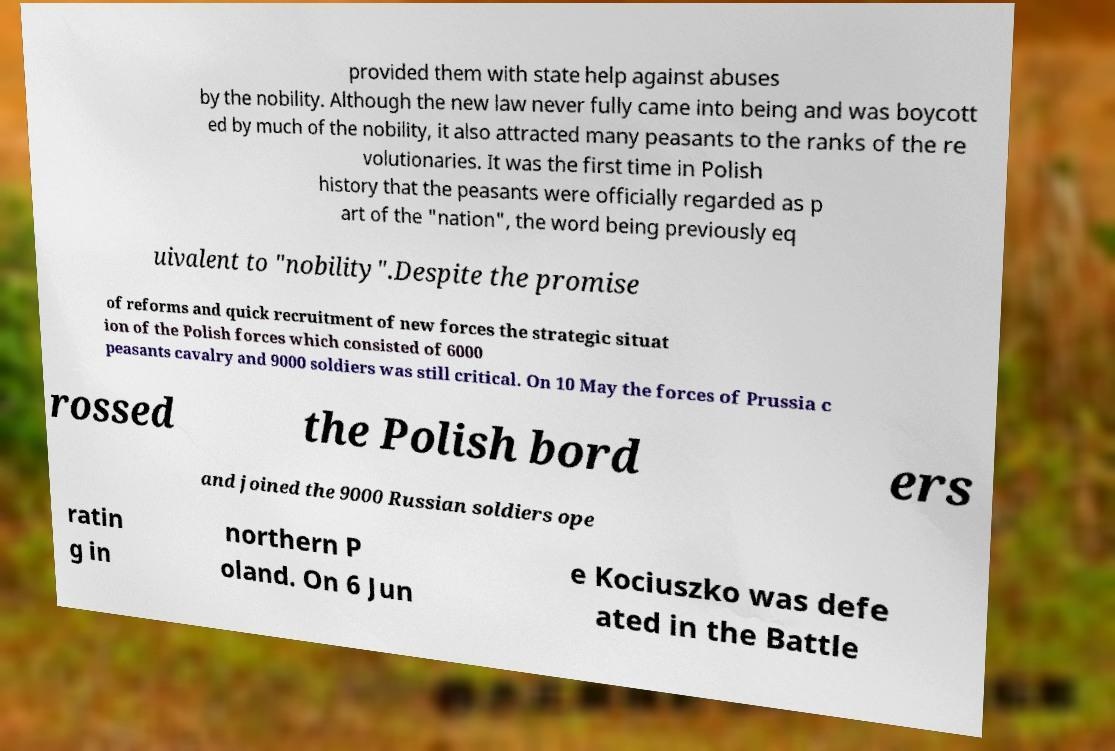There's text embedded in this image that I need extracted. Can you transcribe it verbatim? provided them with state help against abuses by the nobility. Although the new law never fully came into being and was boycott ed by much of the nobility, it also attracted many peasants to the ranks of the re volutionaries. It was the first time in Polish history that the peasants were officially regarded as p art of the "nation", the word being previously eq uivalent to "nobility".Despite the promise of reforms and quick recruitment of new forces the strategic situat ion of the Polish forces which consisted of 6000 peasants cavalry and 9000 soldiers was still critical. On 10 May the forces of Prussia c rossed the Polish bord ers and joined the 9000 Russian soldiers ope ratin g in northern P oland. On 6 Jun e Kociuszko was defe ated in the Battle 